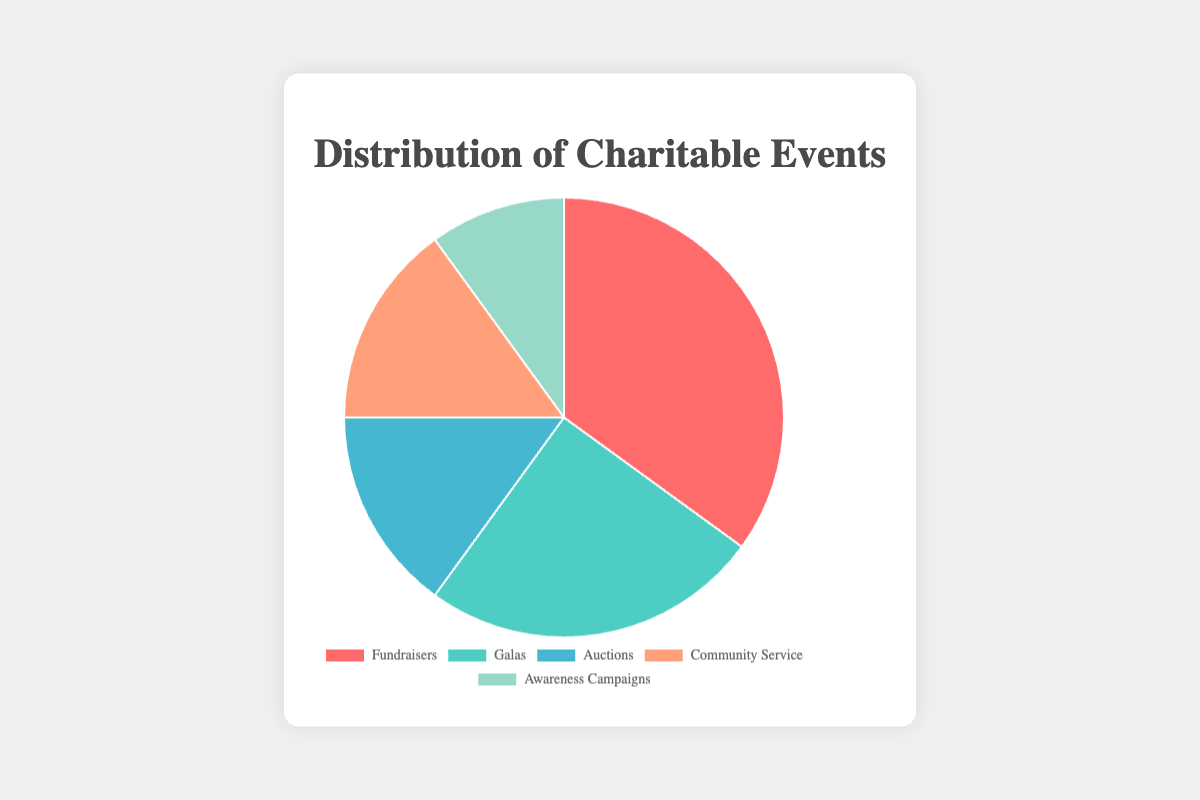What percentage of the events are either Galas or Auctions? First, identify the percentages for Galas (25%) and Auctions (15%). Then, add these percentages together: 25% + 15% = 40%
Answer: 40% Which type of event has the lowest percentage, and what is that percentage? By looking at the pie chart, the type with the smallest segment is Awareness Campaigns, with a percentage of 10%
Answer: Awareness Campaigns, 10% How much greater is the percentage of Fundraisers compared to Awareness Campaigns? Fundraisers have a percentage of 35%, and Awareness Campaigns have 10%. Subtract the smaller percentage from the larger one: 35% - 10% = 25%
Answer: 25% What is the combined percentage of Community Service and Auctions? Community Service and Auctions each have a percentage of 15%. Add these percentages: 15% + 15% = 30%
Answer: 30% Which two types of events together make up 50% of the total? By examining the segments, we see that Fundraisers (35%) and Galas (25%) add up to more than 50%. Next largest pairs are Galas (25%) and Auctions (15%), which is 40%, but Community Service (15%) and Auctions (15%) add up to 30%. Therefore, the closest to 50% is Fundraisers (35%) and Awareness Campaigns (10%): 35% + 15%(Awareness Campaigns) = 50%
Answer: Fundraisers and either Community Service or Auctions Which event type is represented by the green segment, and what percentage does it cover? According to the chart data, the options are Fundraisers, Galas, Auctions, Community Service, and Awareness Campaigns. The green segment correlates with Galas, which covers 25%
Answer: Galas, 25% What percentage of events are not Fundraisers? The percentage for Fundraisers is 35%. Subtract this from 100% to find the percentage of other events: 100% - 35% = 65%
Answer: 65% Are there more types of events with a percentage greater than or equal to 15% or less than 15%? To find out, identify events with percentages greater than or equal to 15% and those less than 15%. Events greater than or equal to 15%: Fundraisers (35%), Galas (25%), Auctions (15%), Community Service (15%). Awareness Campaigns is less than 15% (10%). Since 4 types are ≥ 15% and 1 type < 15%, there are more with ≥ 15%
Answer: Greater than or equal to 15% Which type of event makes up almost one-third of the total percentage? One-third of the total percentage is approximately 33.33%. The closest type to this fraction is Fundraisers, which is 35%
Answer: Fundraisers How does the percentage of Galas compare to that of Community Service and Auctions combined? Percentage for Galas is 25%, while Community Service and Auctions both have 15% each. Combined, Community Service and Auctions are 15% + 15% = 30%. Thus,  Galas (25%) is 5% less than Community Service and Auctions combined (30%)
Answer: 5% less 